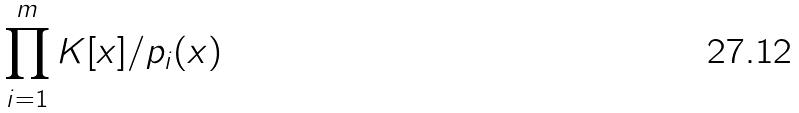<formula> <loc_0><loc_0><loc_500><loc_500>\prod _ { i = 1 } ^ { m } K [ x ] / p _ { i } ( x )</formula> 